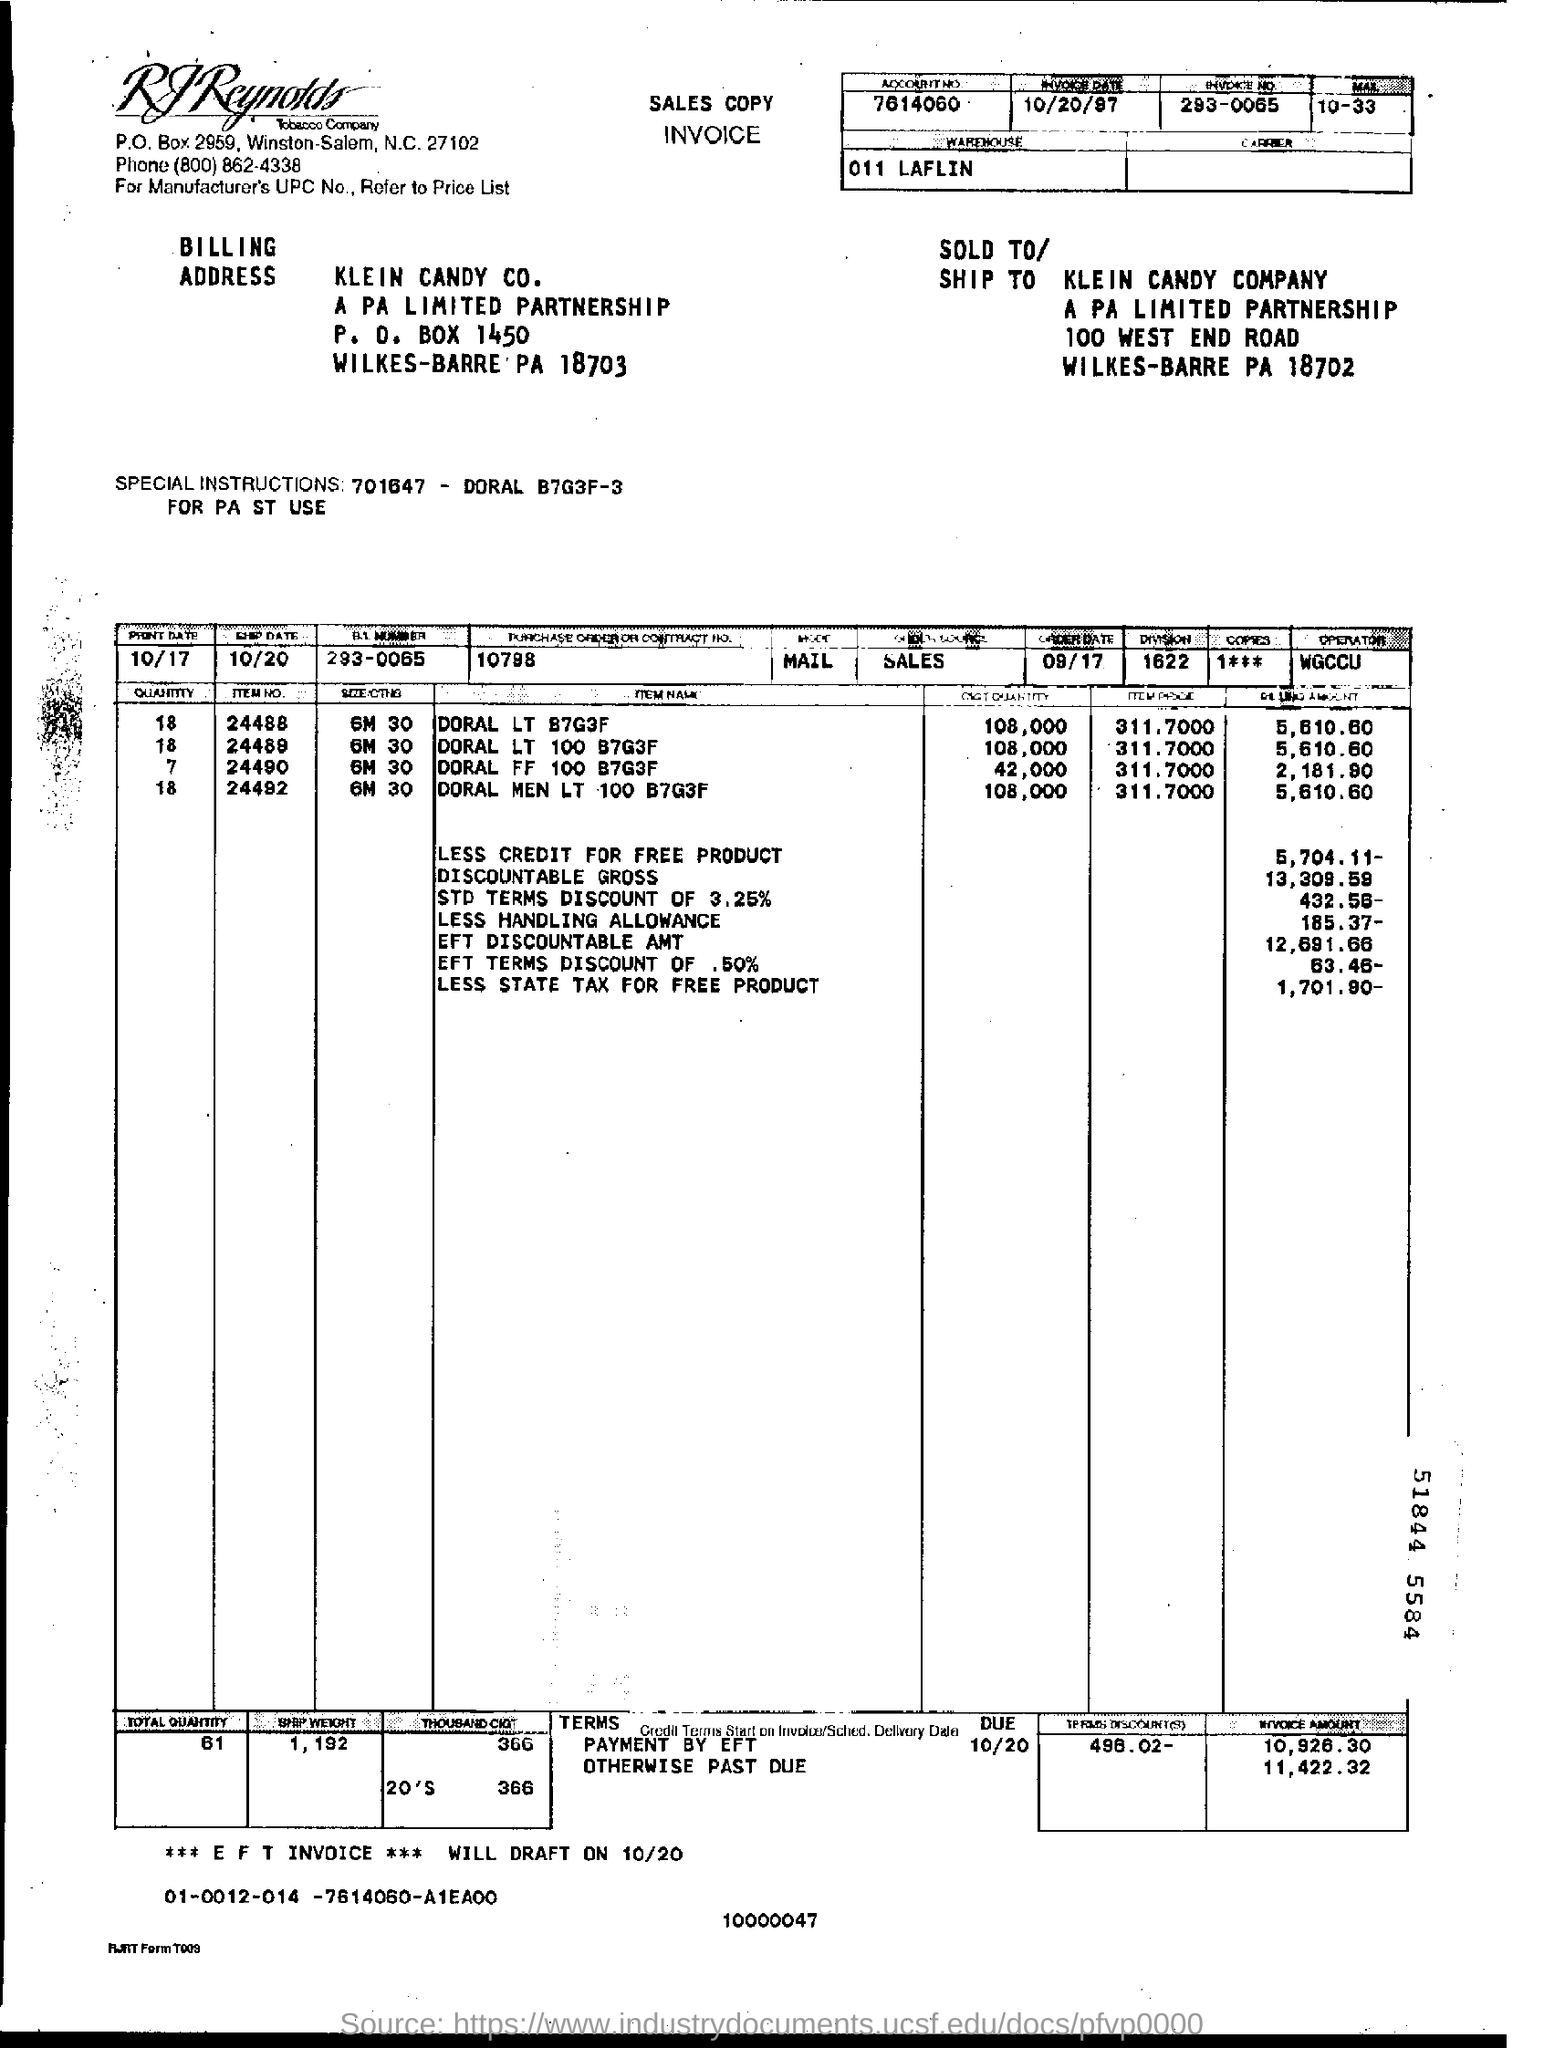What is the account no given in the invoice?
Ensure brevity in your answer.  7614060. What is the invoice no mentioned in the document?
Your answer should be compact. 293-0065. What is the invoice date given in the document?
Your answer should be very brief. 10/20/97. Which company is raising the invoice?
Your answer should be very brief. RJ Reynolds Tobacco Company. What is the payee name mentioned in the invoice?
Your answer should be compact. KLEIN CANDY CO. What is the purchase order or contract no given in the invoice?
Ensure brevity in your answer.  10798. 